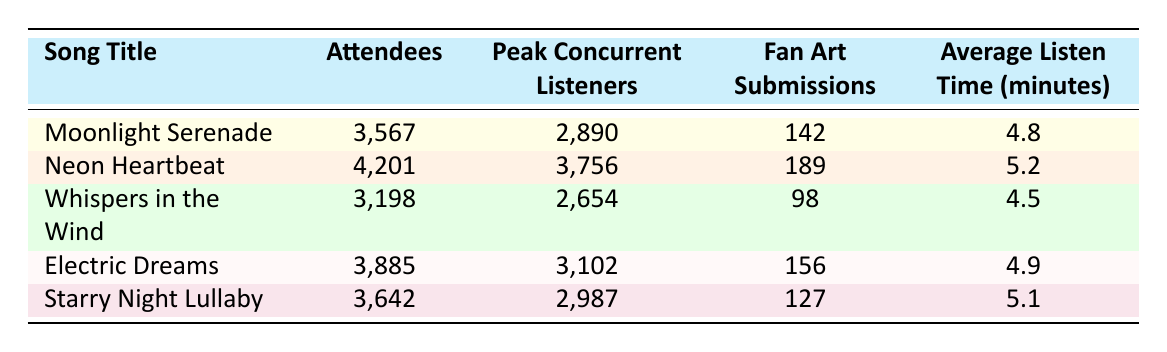What is the song with the highest number of attendees? The table shows the number of attendees for each song. By comparing the values, we see that "Neon Heartbeat" has the highest attendance with 4,201 attendees.
Answer: Neon Heartbeat How many fan art submissions were made for "Electric Dreams"? The table directly states that "Electric Dreams" received 156 fan art submissions.
Answer: 156 What is the average listen time for "Whispers in the Wind"? The average listen time for "Whispers in the Wind" is specified in the table as 4.5 minutes.
Answer: 4.5 Calculate the total number of attendees across all songs. To find the total, we sum the attendees from all songs: 3,567 + 4,201 + 3,198 + 3,885 + 3,642 = 18,493.
Answer: 18493 Is the peak concurrent listener count for "Starry Night Lullaby" higher than for "Moonlight Serenade"? The peak concurrent listeners for "Starry Night Lullaby" is 2,987, while for "Moonlight Serenade" it is 2,890. Since 2,987 is greater than 2,890, the answer is yes.
Answer: Yes Which song has the least number of fan art submissions? By examining the fan art submissions column, "Whispers in the Wind" has the least submissions with 98.
Answer: Whispers in the Wind What is the average of the average listen times for all five songs? Sum the average listen times: 4.8 + 5.2 + 4.5 + 4.9 + 5.1 = 24.5. There are 5 songs, so the average is 24.5 / 5 = 4.9 minutes.
Answer: 4.9 Is there a song that has exactly 3,642 attendees? Looking at the table, "Starry Night Lullaby" has exactly 3,642 attendees, so the answer is yes.
Answer: Yes Which song had the highest peak concurrent listeners? Comparing the peak concurrent listeners, "Neon Heartbeat" has the highest at 3,756.
Answer: Neon Heartbeat 